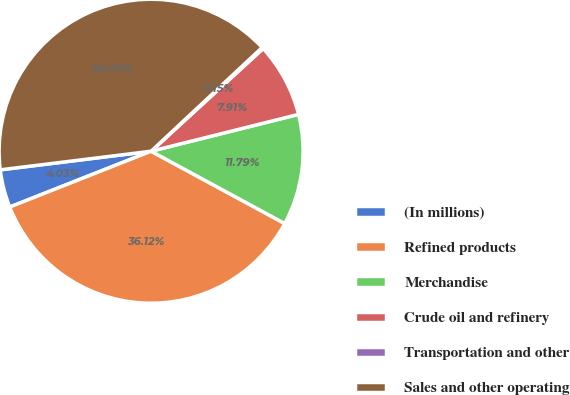<chart> <loc_0><loc_0><loc_500><loc_500><pie_chart><fcel>(In millions)<fcel>Refined products<fcel>Merchandise<fcel>Crude oil and refinery<fcel>Transportation and other<fcel>Sales and other operating<nl><fcel>4.03%<fcel>36.12%<fcel>11.79%<fcel>7.91%<fcel>0.15%<fcel>40.0%<nl></chart> 